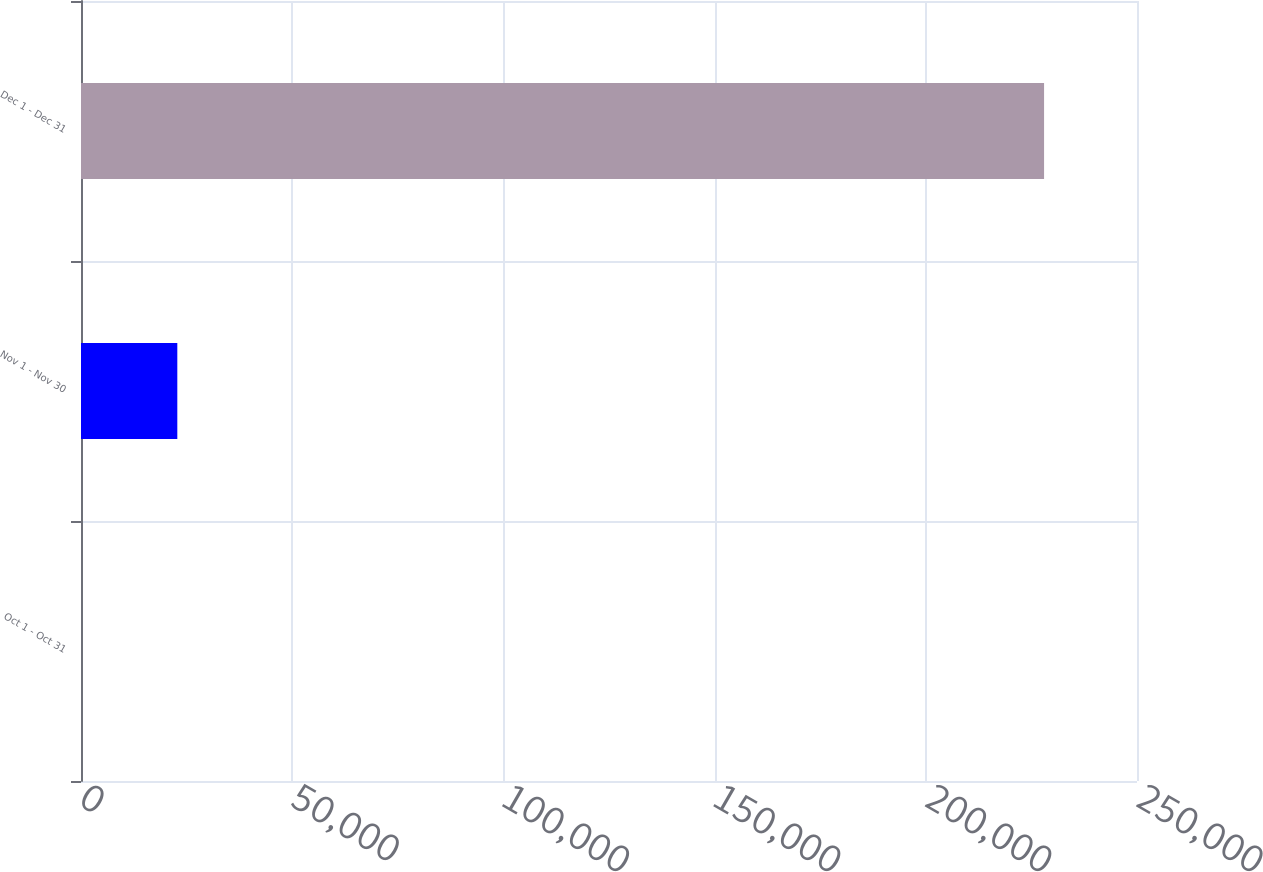<chart> <loc_0><loc_0><loc_500><loc_500><bar_chart><fcel>Oct 1 - Oct 31<fcel>Nov 1 - Nov 30<fcel>Dec 1 - Dec 31<nl><fcel>0.41<fcel>22800.4<fcel>228000<nl></chart> 